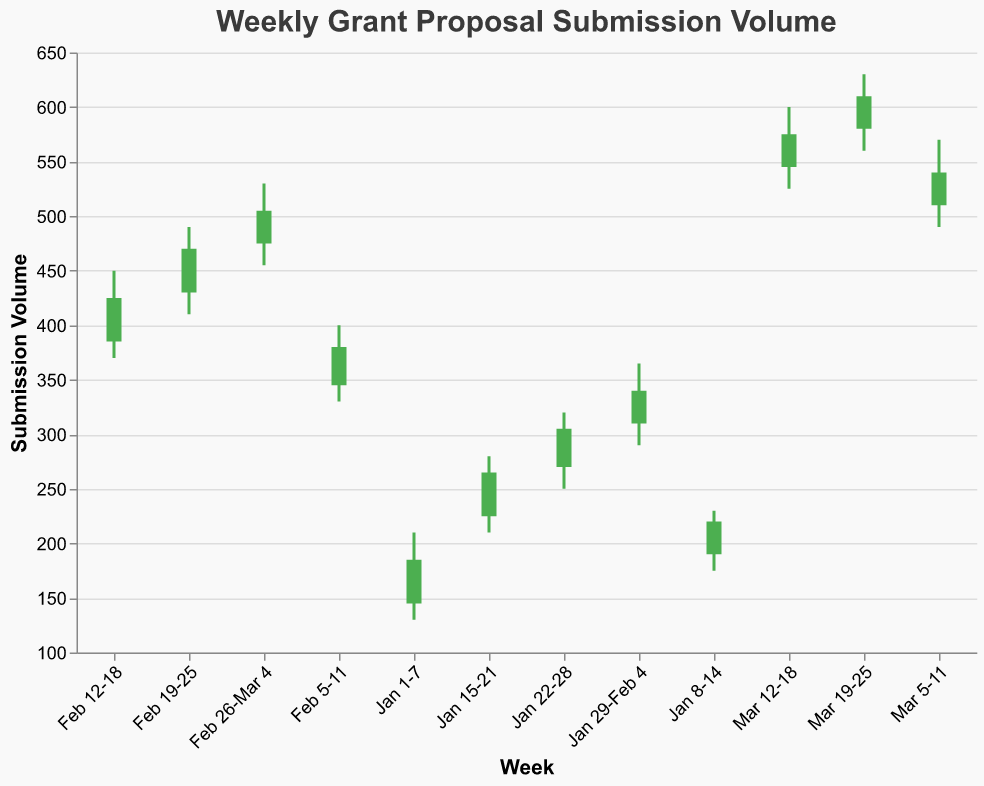What is the title of the figure? The title of the figure is displayed at the top and provides an overview of the content.
Answer: Weekly Grant Proposal Submission Volume During which week did the submission volume reach its highest point? Examine the "High" values across all the weeks to find the maximum value. The highest "High" value is 630 during the week of Mar 19-25.
Answer: Mar 19-25 Which week shows the largest difference between the "High" and "Low" values? Calculate the difference between "High" and "Low" for each week, then compare them. The largest difference (80 units) is during the week of Mar 19-25 (630 - 560 = 70).
Answer: Mar 19-25 Is there a week where the "Close" value is lower than the "Open" value? Compare the "Open" and "Close" values for all weeks. No weeks have a "Close" value lower than the "Open" value; all weeks have "Close" values equal to or higher than "Open".
Answer: No Between which weeks does the largest weekly increase in the "Close" value occur? Calculate the difference in "Close" values between consecutive weeks; find the maximum increase. The largest increase is between Feb 19-25 and Feb 26-Mar 4, where the "Close" increases from 470 to 505 (an increase of 35 units).
Answer: Feb 19-25 to Feb 26-Mar 4 Which week has the smallest range between "Open" and "Close" values? Calculate the range (difference) between "Open" and "Close" for each week and find the smallest range. The smallest range is during Jan 8-14, where the range is 30 units (220 - 190 = 30).
Answer: Jan 8-14 How many weeks show an increasing trend from "Open" to "Close"? Count the weeks where the "Close" value is higher than the "Open" value. All weeks show an increasing trend from "Open" to "Close".
Answer: 12 What is the average "Close" value during the entire period? Sum all "Close" values and divide by the total number of weeks. (185 + 220 + 265 + 305 + 340 + 380 + 425 + 470 + 505 + 540 + 575 + 610) / 12 = 393.75
Answer: 393.75 What is the overall trend in the weekly grant proposal submission volume? The values (Open, High, Low, Close) consistently increase over the weeks from Jan 1-7 to Mar 19-25, indicating an overall upward trend in the submission volume.
Answer: Upward trend Which week has the highest "Low" value and what is it? Examine the "Low" values to find the maximum. The highest "Low" value is 560 during the week of Mar 19-25.
Answer: Mar 19-25 